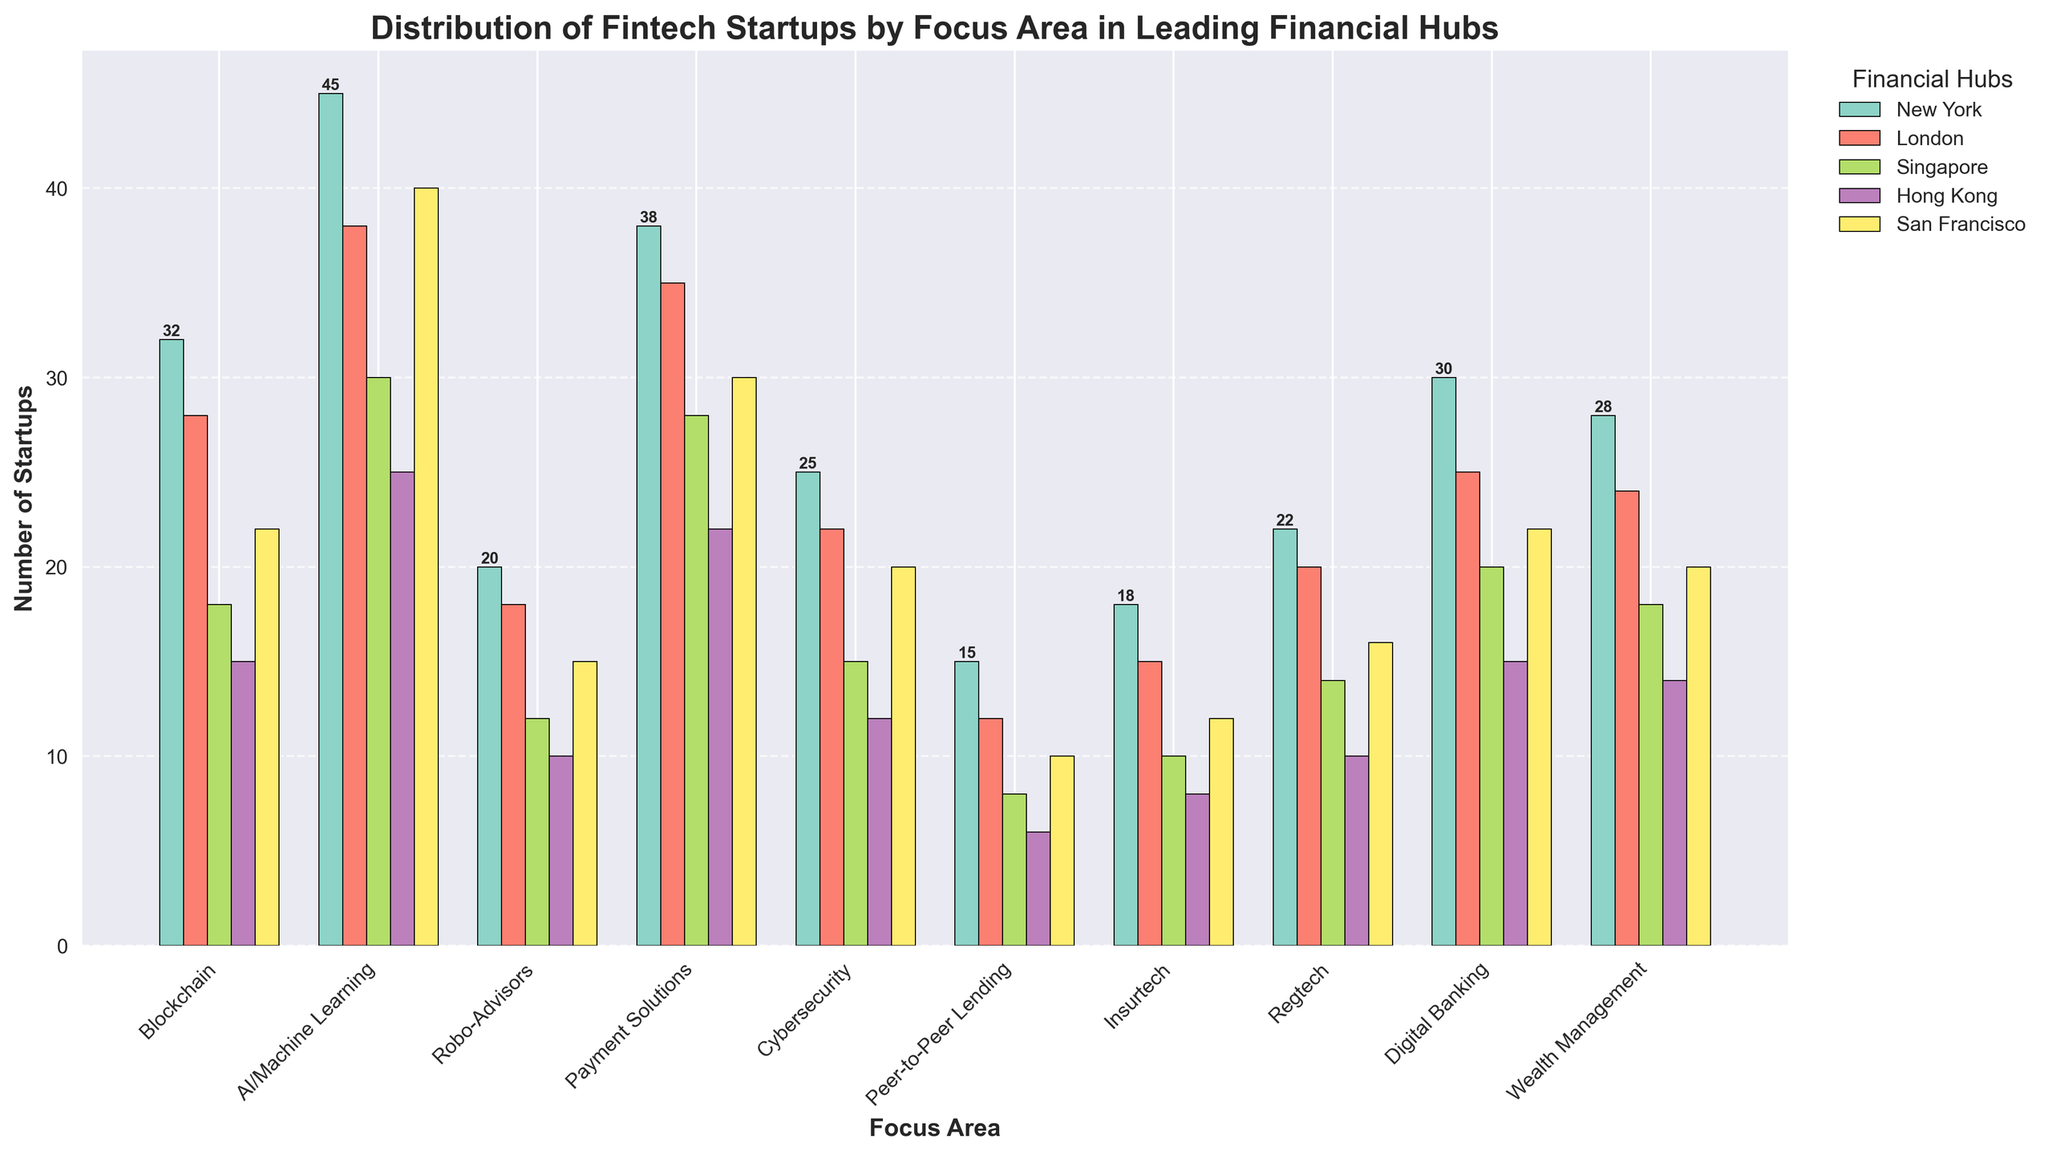Which financial hub has the highest number of fintech startups focusing on AI/Machine Learning? By looking at the bar heights for AI/Machine Learning across the different financial hubs, New York has the highest bar.
Answer: New York Which focus area has the least number of startups in Hong Kong? By comparing the heights of bars for different focus areas in Hong Kong, Peer-to-Peer Lending has the shortest bar.
Answer: Peer-to-Peer Lending How many more fintech startups focus on Payment Solutions in London compared to Singapore? Subtract the number of fintech startups focusing on Payment Solutions in Singapore (28) from those in London (35): 35 - 28 = 7
Answer: 7 Which city has more fintech startups focusing on Cybersecurity, New York or San Francisco? By comparing the bar heights for Cybersecurity between New York and San Francisco, New York has a higher bar with 25 compared to San Francisco's 20.
Answer: New York What is the average number of fintech startups focusing on Digital Banking across San Francisco, Hong Kong, and Singapore? Sum the number of startups from each of these cities for Digital Banking and divide by the count of cities: (22 + 15 + 20) / 3 = 57 / 3 = 19
Answer: 19 Are there more fintech startups in San Francisco focusing on Blockchain compared to those in Robo-Advisors and Insurtech combined? Add the number of startups in San Francisco for Robo-Advisors (15) and Insurtech (12): 15 + 12 = 27. The number for Blockchain is 22, which is less than 27.
Answer: No Which focus area has the highest combined number of startups in New York and London? Add up the numbers of each focus area in New York and London to find the one with the highest sum. AI/Machine Learning has the highest combined number: 45 (New York) + 38 (London) = 83.
Answer: AI/Machine Learning What is the difference between the highest and lowest number of startups across all focus areas in Singapore? Find the highest (AI/Machine Learning with 30) and lowest (Peer-to-Peer Lending with 8) number of startups in Singapore and calculate the difference: 30 - 8 = 22.
Answer: 22 How many more fintech startups in New York focus on Peer-to-Peer Lending compared to Hong Kong? Subtract the number of startups in Hong Kong (6) from those in New York (15): 15 - 6 = 9.
Answer: 9 Which city has the most similar number of fintech startups focusing on Digital Banking as Hong Kong? Compare Hong Kong's number (15) with the other cities. San Francisco and Blockchain both have 22, which differs from Hong Kong's 15 by 7. Singapore has 20, differing by 5.
Answer: Singapore 